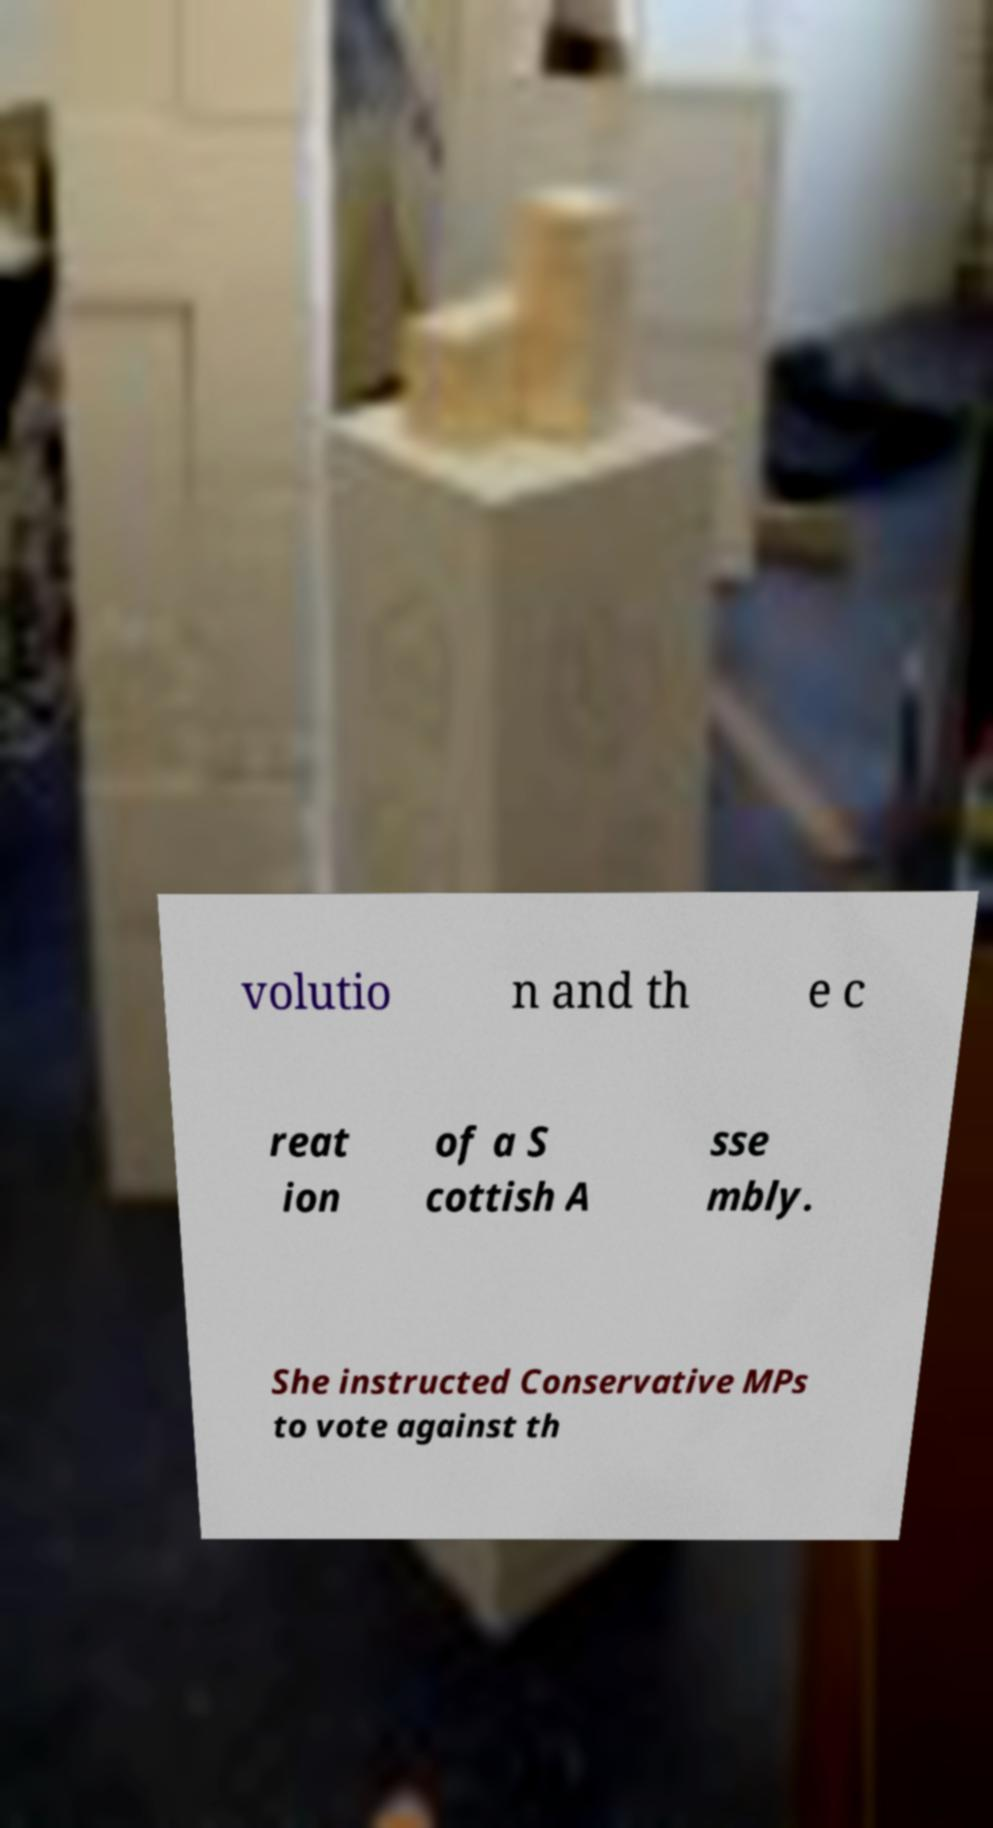Can you read and provide the text displayed in the image?This photo seems to have some interesting text. Can you extract and type it out for me? volutio n and th e c reat ion of a S cottish A sse mbly. She instructed Conservative MPs to vote against th 